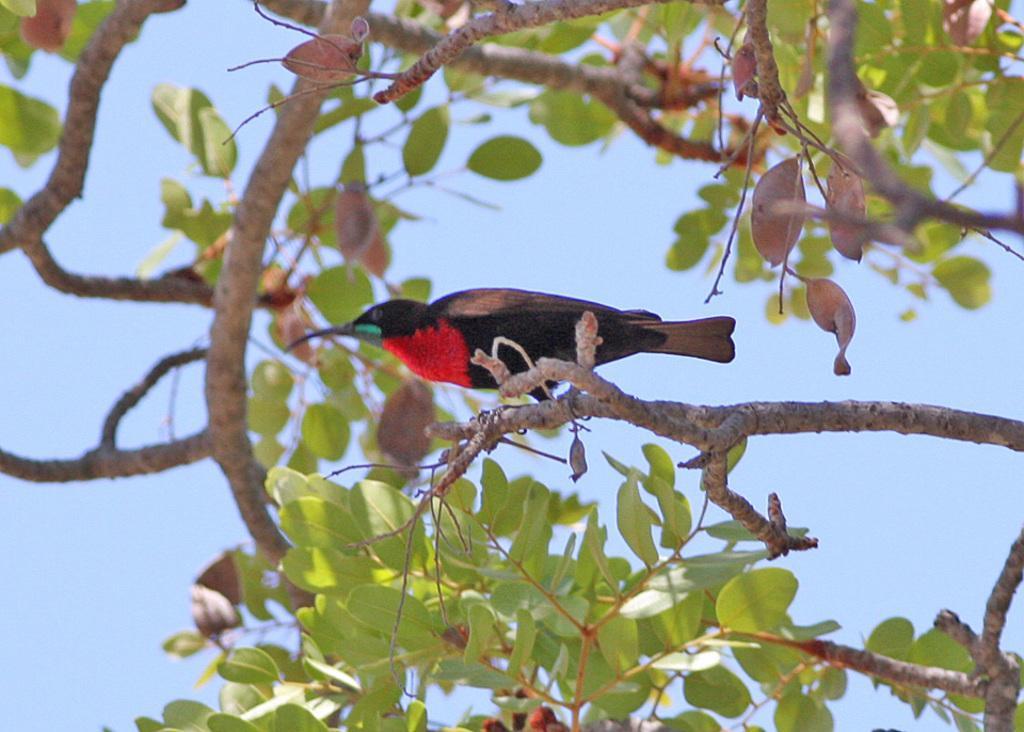Could you give a brief overview of what you see in this image? In the image we can see there is a bird sitting on the tree. 